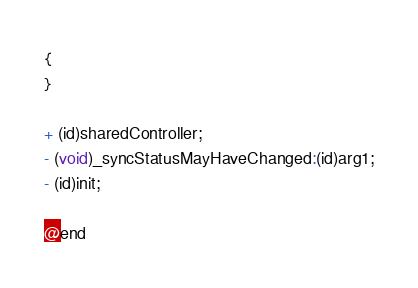<code> <loc_0><loc_0><loc_500><loc_500><_C_>{
}

+ (id)sharedController;
- (void)_syncStatusMayHaveChanged:(id)arg1;
- (id)init;

@end

</code> 